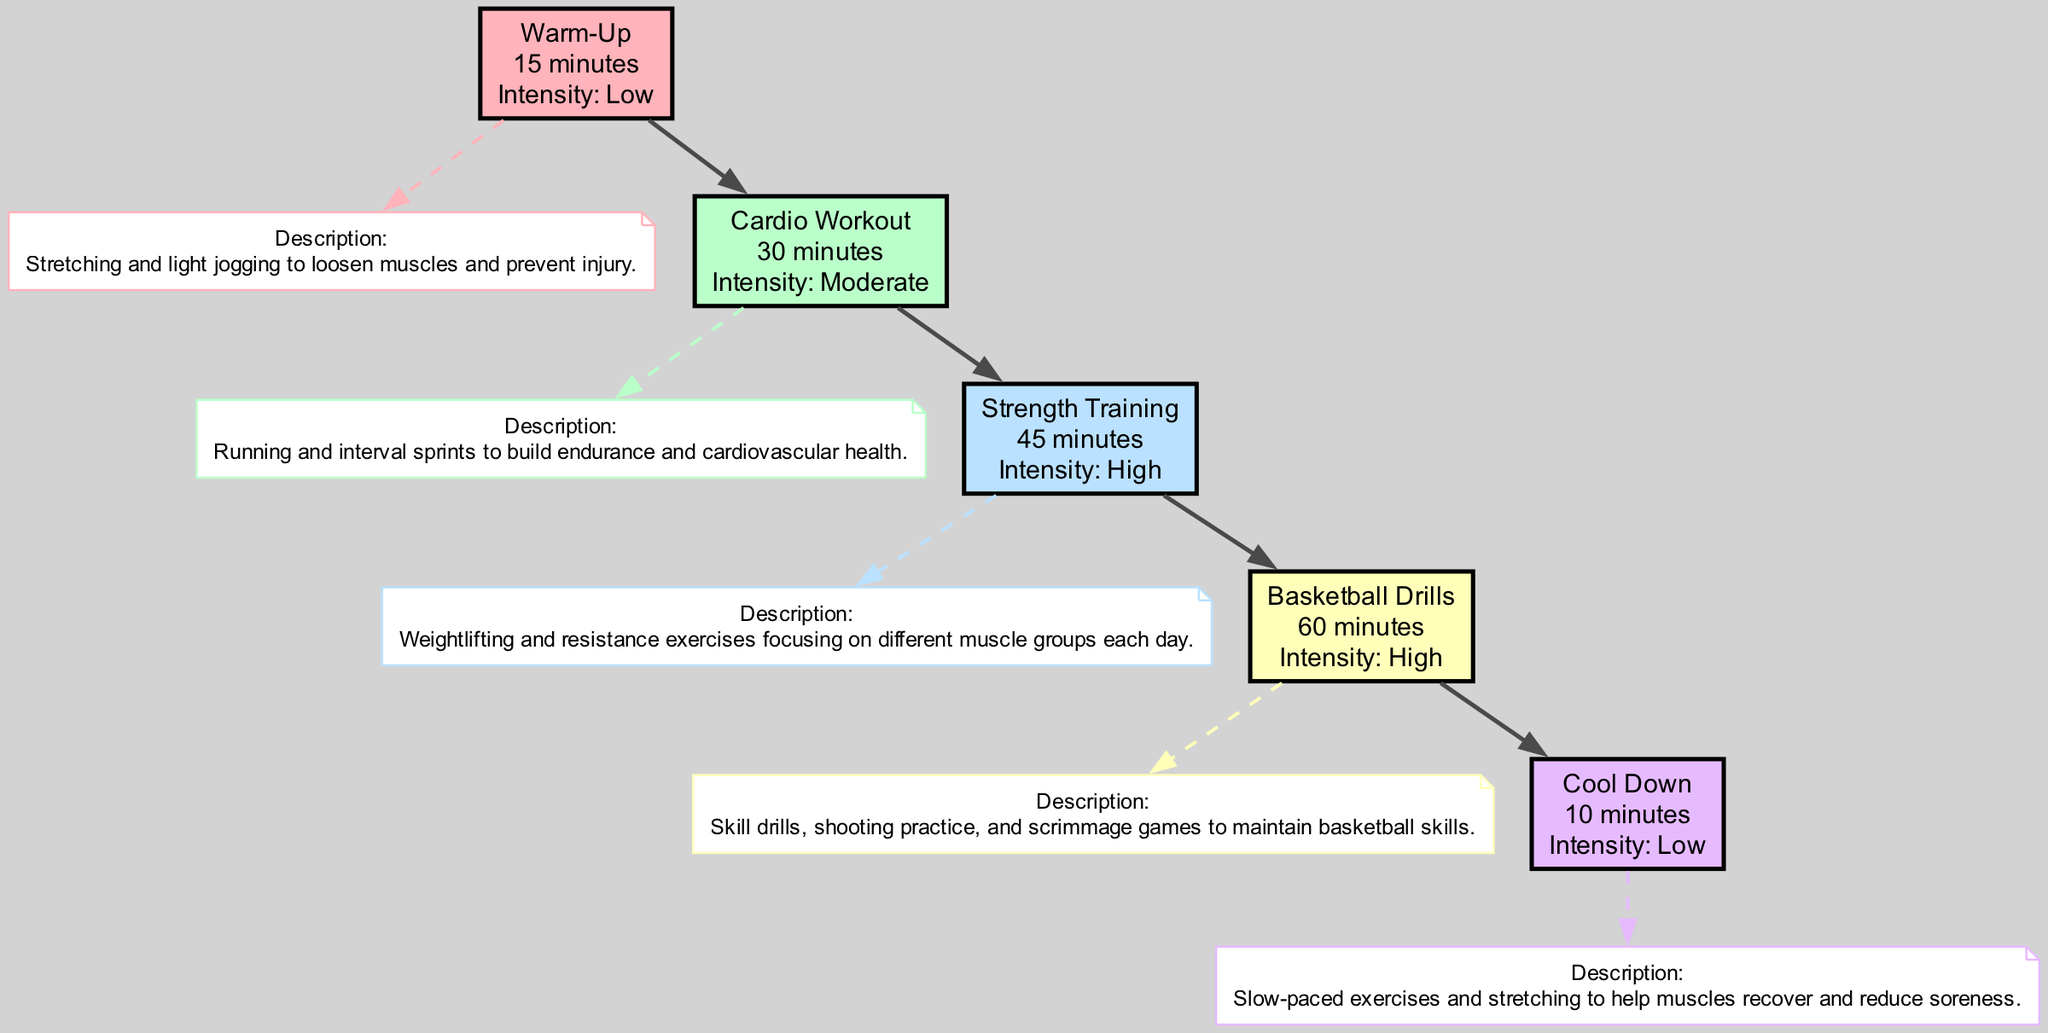What is the time allocation for the Strength Training block? The Strength Training block specifically states it lasts for "45 minutes," which is clearly indicated in the block information.
Answer: 45 minutes Which block has the highest intensity level? Evaluating the intensity levels, both the Strength Training and Basketball Drills blocks are marked as "High," indicating they share the highest intensity level overall.
Answer: High What description corresponds to the Basketball Drills? By looking at the Basketball Drills block, the description provided is "Skill drills, shooting practice, and scrimmage games to maintain basketball skills," directly detailing the activities involved.
Answer: Skill drills, shooting practice, and scrimmage games to maintain basketball skills How many minutes are allocated in total for the cardio workout and basketball drills combined? By adding the Cardio Workout (30 minutes) and Basketball Drills (60 minutes), the total time is 90 minutes (30 + 60 = 90) when combining these two specific blocks.
Answer: 90 minutes Which block comes first in the fitness routine? The first block in the sequence, as depicted in the diagram, is the Warm-Up block, which is positioned at the very top of the flow.
Answer: Warm-Up Which two blocks are marked with low intensity? Referring to the diagram, the Warm-Up and Cool Down blocks are both categorized as having low intensity, marking a clear distinction from the others.
Answer: Warm-Up and Cool Down What is the purpose of the Cool Down block? The purpose stated for the Cool Down block is "Slow-paced exercises and stretching to help muscles recover and reduce soreness," informing of its specific role in the routine.
Answer: Slow-paced exercises and stretching to help muscles recover and reduce soreness How many total blocks are displayed in the diagram? Counting each block as present in the diagram yields a total of five blocks: Warm-Up, Cardio Workout, Strength Training, Basketball Drills, and Cool Down.
Answer: 5 blocks What is the time allocated for the Warm-Up? The Warm-Up block clearly specifies a time of "15 minutes," directly indicating the duration of this initial activity.
Answer: 15 minutes 